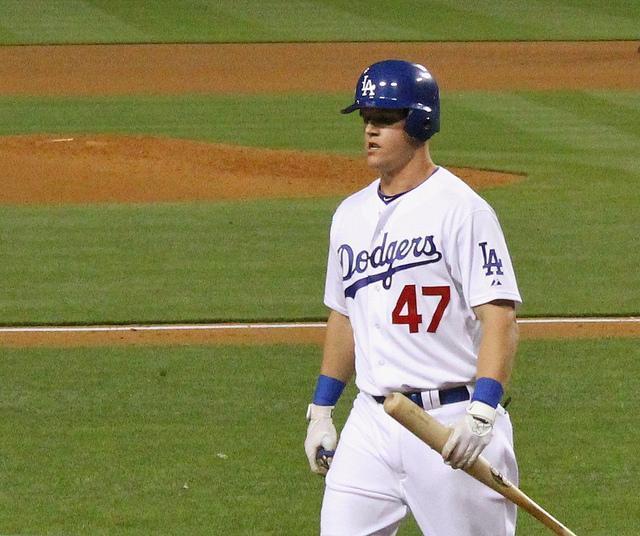How many little elephants are in the image?
Give a very brief answer. 0. 